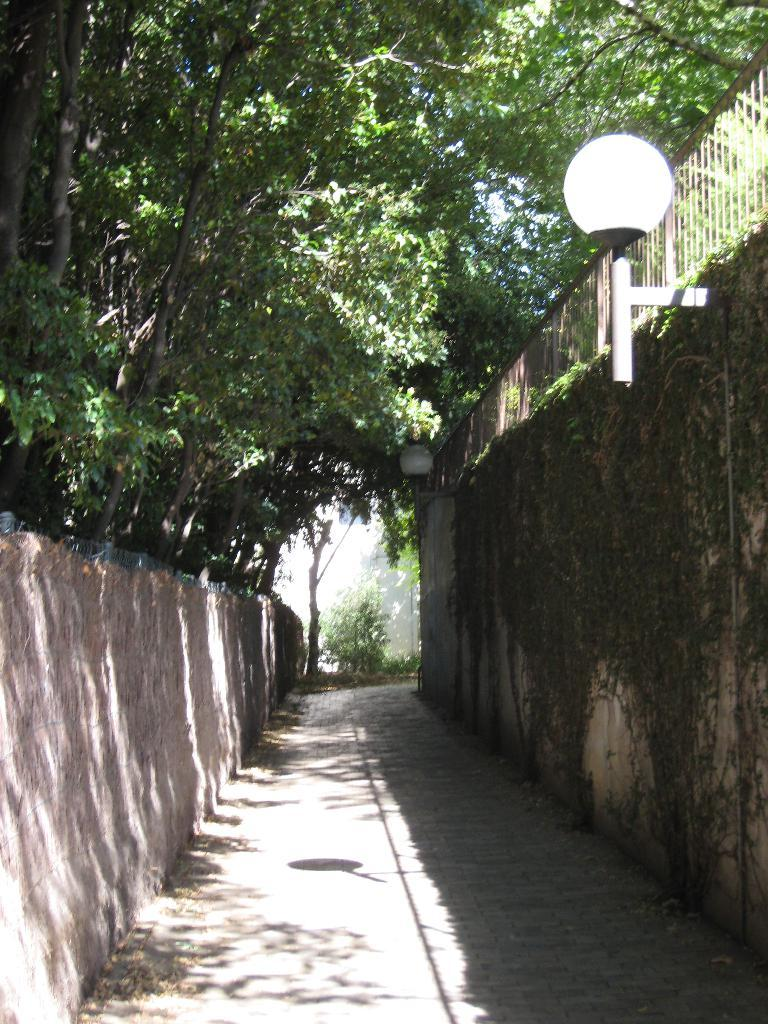What type of natural elements can be seen in the image? There are trees in the image. What artificial elements can be seen in the image? There are lights, walls, and a fence in the image. What is the weight of the turkey in the image? There is no turkey present in the image, so its weight cannot be determined. What form does the turkey take in the image? There is no turkey present in the image, so its form cannot be described. 